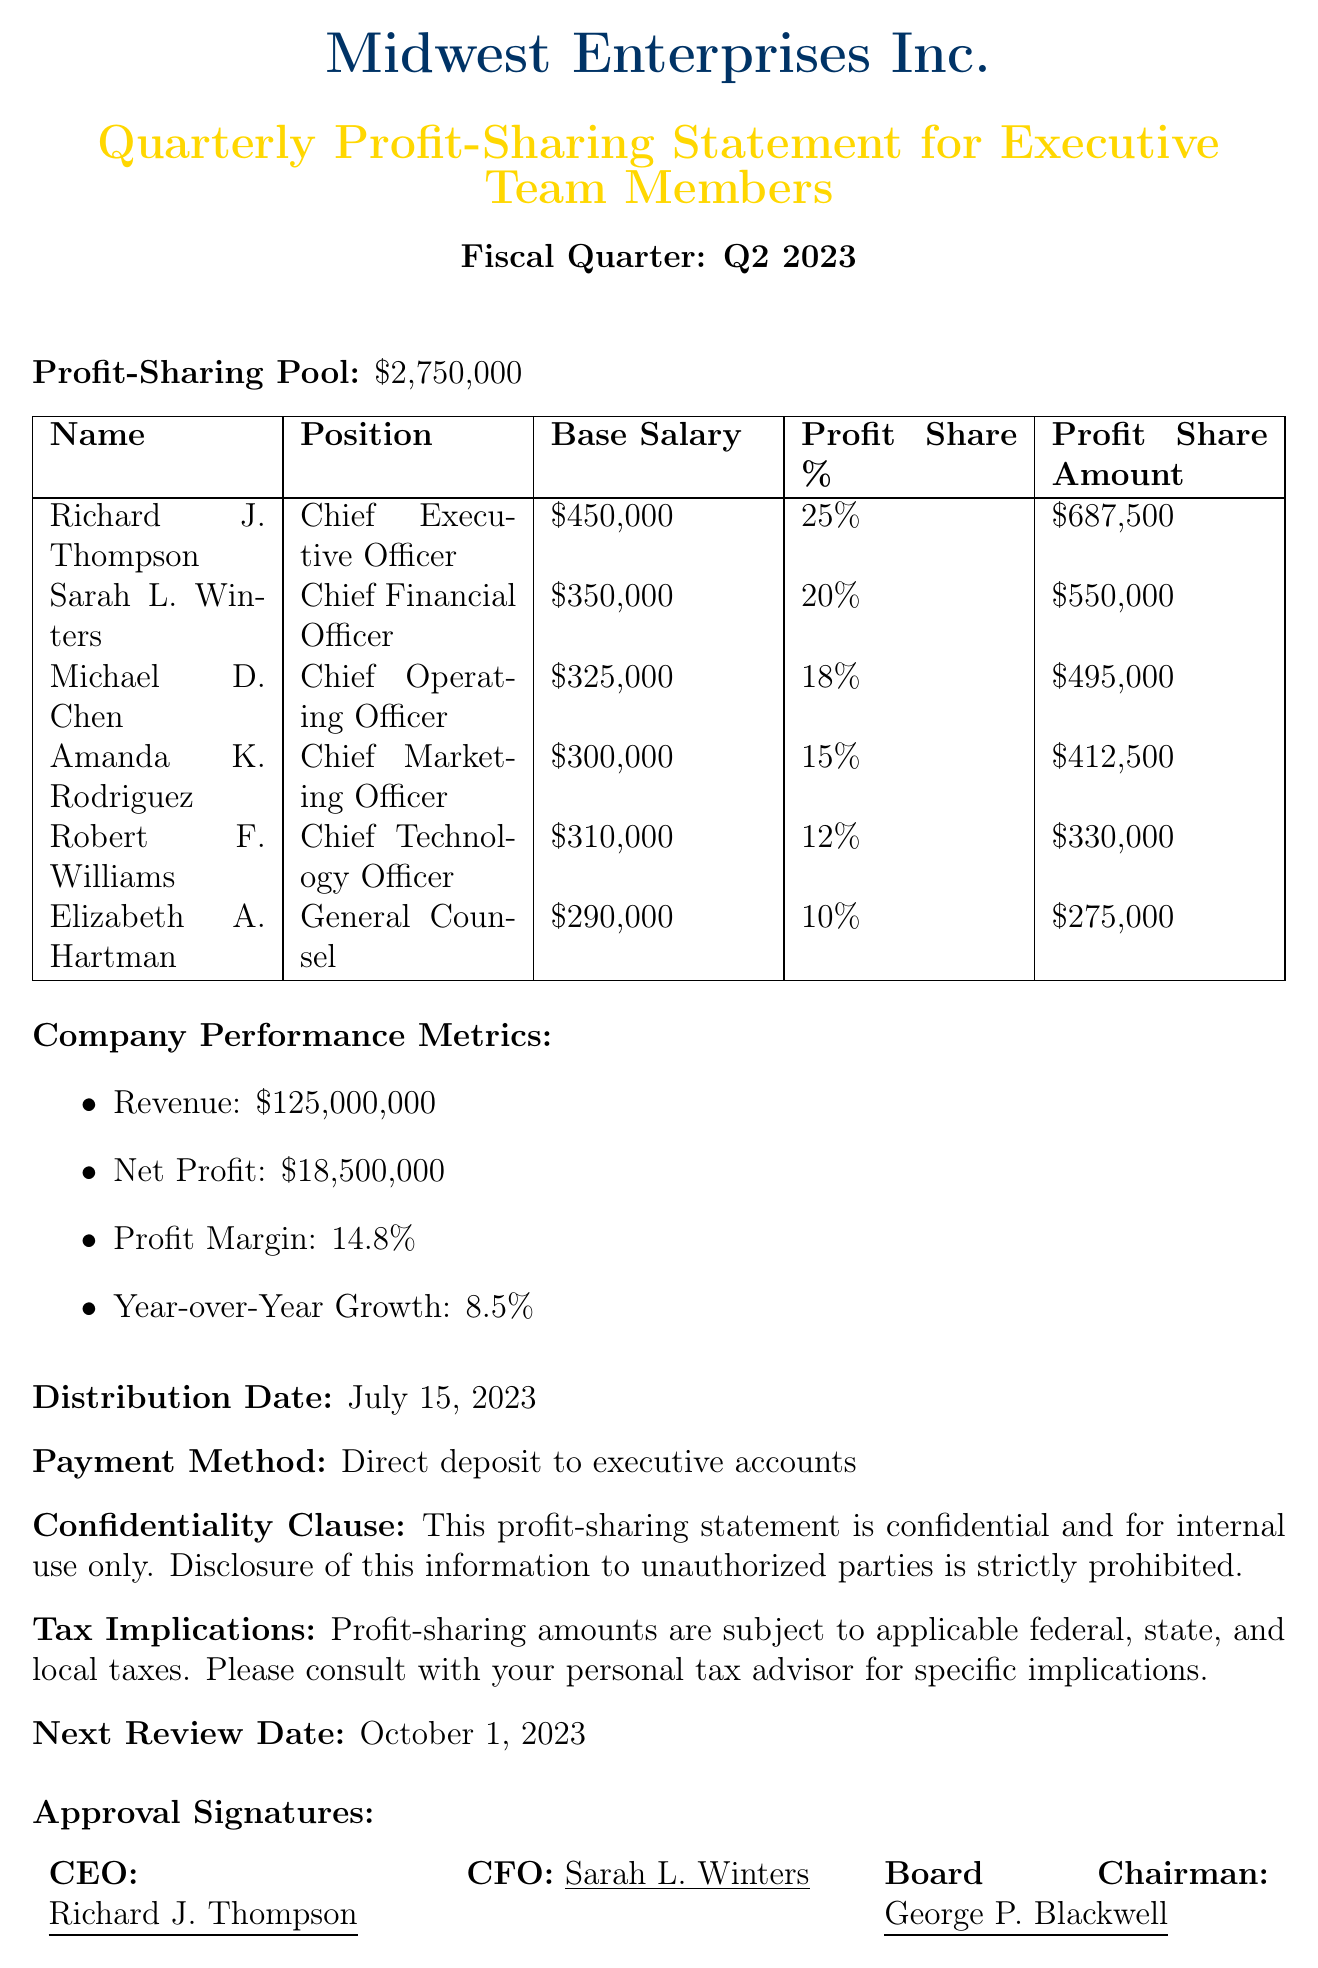What is the company name? The document states the company name at the top, which is Midwest Enterprises Inc.
Answer: Midwest Enterprises Inc Who is the Chief Executive Officer? The document lists Richard J. Thompson as the Chief Executive Officer in the executive team section.
Answer: Richard J. Thompson What is the base salary of the Chief Financial Officer? The document specifies Sarah L. Winters' base salary as $350,000.
Answer: $350,000 What is the profit-sharing pool amount? The profit-sharing pool amount is mentioned in the document and is $2,750,000.
Answer: $2,750,000 What is the profit share percentage for the Chief Operating Officer? The Chief Operating Officer, Michael D. Chen, has a profit share percentage of 18%.
Answer: 18% How much is the profit share amount for the General Counsel? The profit share amount for Elizabeth A. Hartman is explicitly listed as $275,000.
Answer: $275,000 What is the distribution date of the profit-sharing statement? The document clearly states that the distribution date is July 15, 2023.
Answer: July 15, 2023 What are the criteria for determining profit sharing? The document lists various factors, including individual performance evaluations and department performance metrics, as criteria.
Answer: Individual performance evaluations, department performance metrics, company-wide financial goals achievement, market share growth in key regions, implementation of cost-saving initiatives What is the tax implication mentioned in the document? The document indicates that profit-sharing amounts are subject to applicable federal, state, and local taxes.
Answer: Subject to applicable federal, state, and local taxes When is the next review date stated in the document? The next review date is explicitly mentioned as October 1, 2023.
Answer: October 1, 2023 